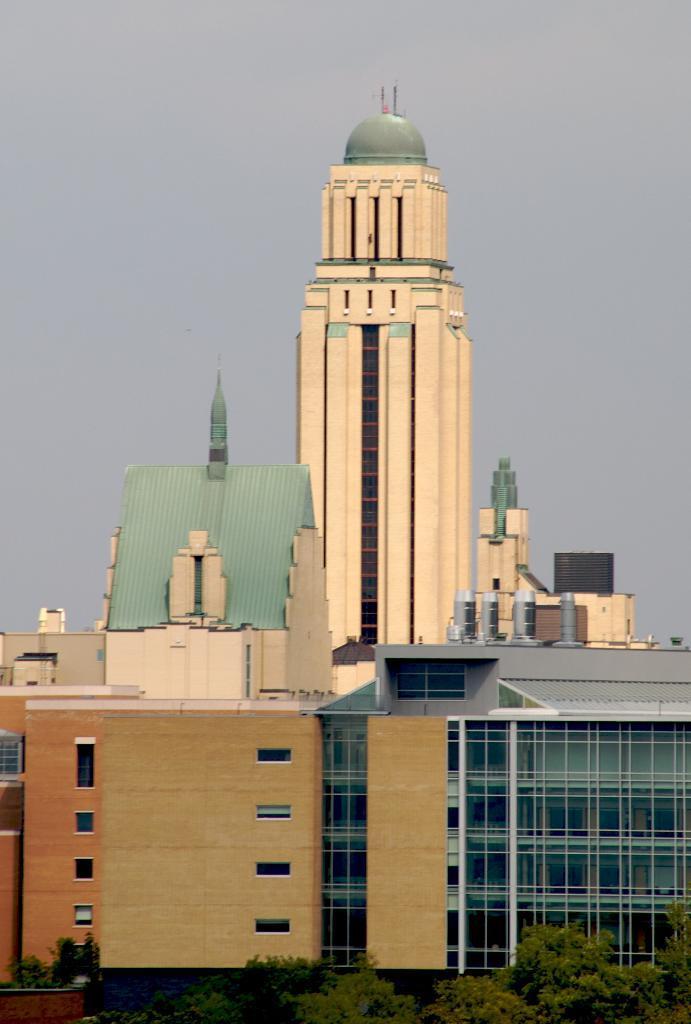Can you describe this image briefly? In this image I can see many trees and the buildings. In the background I can see the sky. 